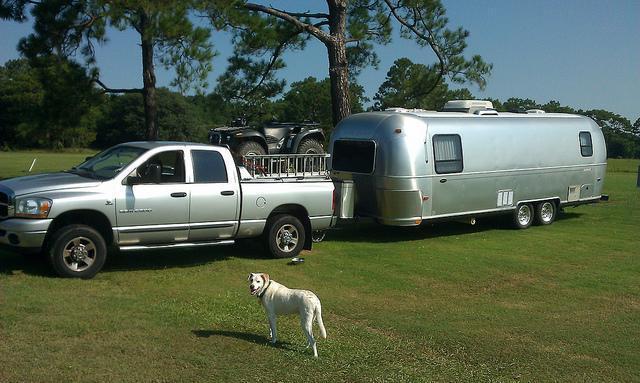How many trucks are in the photo?
Give a very brief answer. 2. 